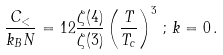Convert formula to latex. <formula><loc_0><loc_0><loc_500><loc_500>\frac { C _ { < } } { k _ { B } N } = 1 2 \frac { \zeta ( 4 ) } { \zeta ( 3 ) } \left ( \frac { T } { T _ { c } } \right ) ^ { 3 } \, ; \, k = 0 \, .</formula> 